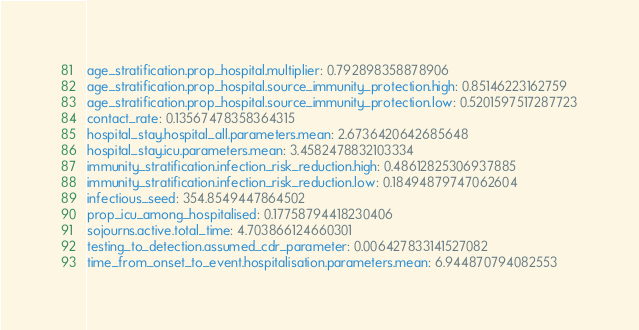<code> <loc_0><loc_0><loc_500><loc_500><_YAML_>age_stratification.prop_hospital.multiplier: 0.792898358878906
age_stratification.prop_hospital.source_immunity_protection.high: 0.85146223162759
age_stratification.prop_hospital.source_immunity_protection.low: 0.5201597517287723
contact_rate: 0.13567478358364315
hospital_stay.hospital_all.parameters.mean: 2.6736420642685648
hospital_stay.icu.parameters.mean: 3.4582478832103334
immunity_stratification.infection_risk_reduction.high: 0.48612825306937885
immunity_stratification.infection_risk_reduction.low: 0.18494879747062604
infectious_seed: 354.8549447864502
prop_icu_among_hospitalised: 0.17758794418230406
sojourns.active.total_time: 4.703866124660301
testing_to_detection.assumed_cdr_parameter: 0.006427833141527082
time_from_onset_to_event.hospitalisation.parameters.mean: 6.944870794082553</code> 